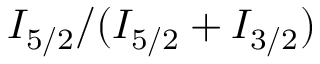Convert formula to latex. <formula><loc_0><loc_0><loc_500><loc_500>I _ { 5 / 2 } / ( I _ { 5 / 2 } + I _ { 3 / 2 } )</formula> 